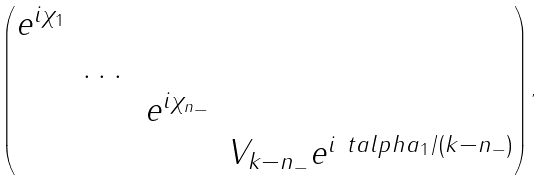<formula> <loc_0><loc_0><loc_500><loc_500>\begin{pmatrix} e ^ { i \chi _ { 1 } } & & & \\ & \dots & & \\ & & e ^ { i \chi _ { n _ { - } } } & \\ & & & V _ { k - n _ { - } } e ^ { i \ t a l p h a _ { 1 } / ( k - n _ { - } ) } \end{pmatrix} ,</formula> 